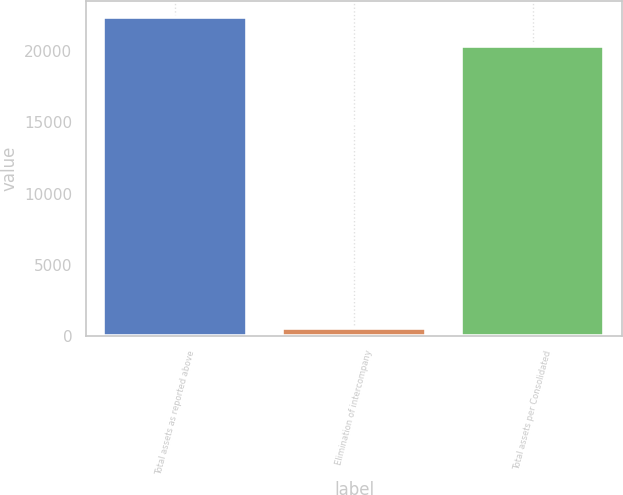Convert chart to OTSL. <chart><loc_0><loc_0><loc_500><loc_500><bar_chart><fcel>Total assets as reported above<fcel>Elimination of intercompany<fcel>Total assets per Consolidated<nl><fcel>22403.7<fcel>539<fcel>20367<nl></chart> 